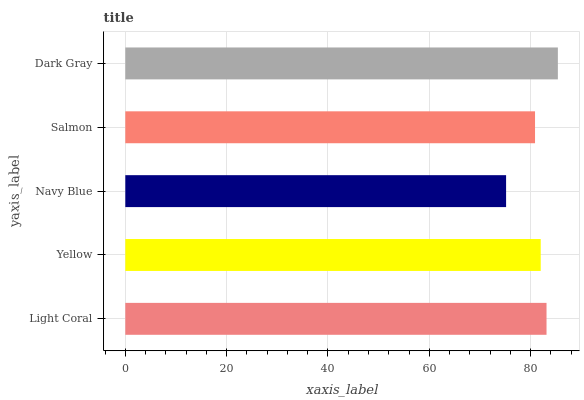Is Navy Blue the minimum?
Answer yes or no. Yes. Is Dark Gray the maximum?
Answer yes or no. Yes. Is Yellow the minimum?
Answer yes or no. No. Is Yellow the maximum?
Answer yes or no. No. Is Light Coral greater than Yellow?
Answer yes or no. Yes. Is Yellow less than Light Coral?
Answer yes or no. Yes. Is Yellow greater than Light Coral?
Answer yes or no. No. Is Light Coral less than Yellow?
Answer yes or no. No. Is Yellow the high median?
Answer yes or no. Yes. Is Yellow the low median?
Answer yes or no. Yes. Is Navy Blue the high median?
Answer yes or no. No. Is Salmon the low median?
Answer yes or no. No. 